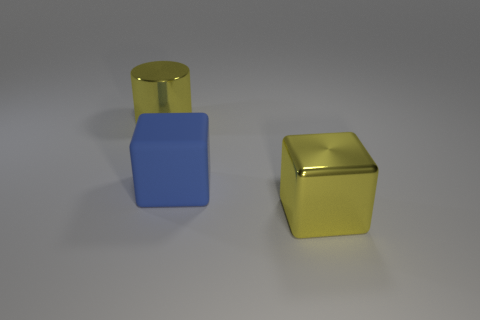What number of yellow things have the same size as the yellow cylinder?
Offer a very short reply. 1. Does the yellow metal thing on the right side of the metallic cylinder have the same size as the large blue rubber cube?
Offer a very short reply. Yes. There is a large blue block; are there any things right of it?
Provide a short and direct response. Yes. Are there the same number of blue things on the right side of the rubber object and big rubber things on the right side of the large metallic cylinder?
Your answer should be compact. No. How many other objects are there of the same material as the big cylinder?
Offer a very short reply. 1. How many tiny things are either blocks or yellow shiny cubes?
Make the answer very short. 0. Are there an equal number of metallic things that are behind the big matte block and large yellow blocks?
Your response must be concise. Yes. Are there any yellow metallic cubes that are behind the yellow metal thing that is to the right of the yellow cylinder?
Make the answer very short. No. How many other objects are there of the same color as the matte block?
Provide a short and direct response. 0. What color is the big rubber block?
Ensure brevity in your answer.  Blue. 